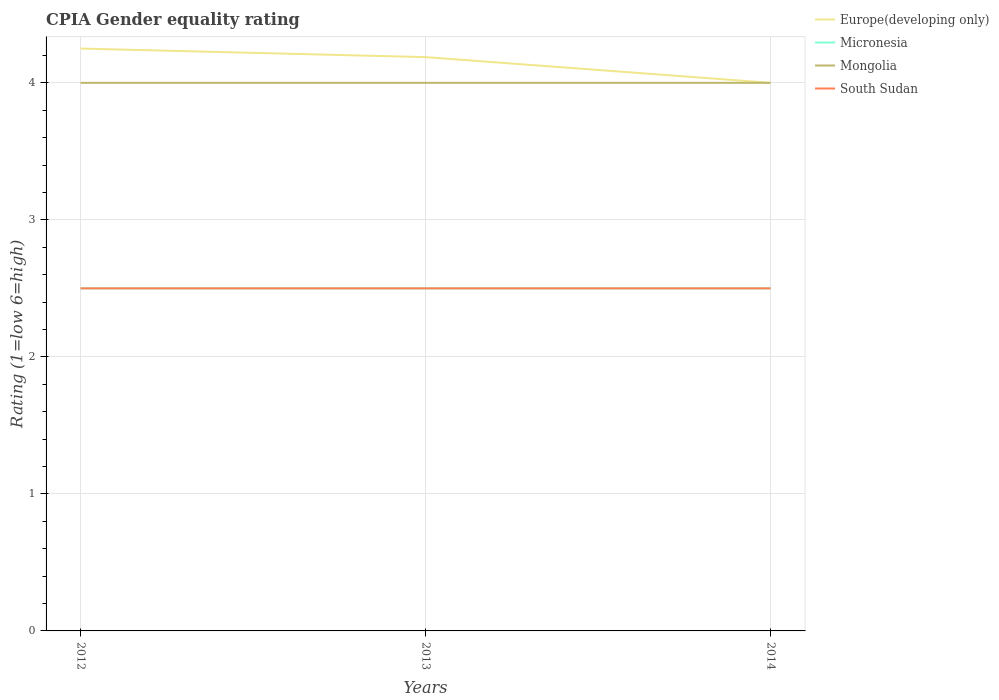How many different coloured lines are there?
Your answer should be very brief. 4. Does the line corresponding to Europe(developing only) intersect with the line corresponding to South Sudan?
Give a very brief answer. No. Across all years, what is the maximum CPIA rating in Europe(developing only)?
Keep it short and to the point. 4. What is the difference between the highest and the lowest CPIA rating in Europe(developing only)?
Provide a succinct answer. 2. Is the CPIA rating in Europe(developing only) strictly greater than the CPIA rating in South Sudan over the years?
Make the answer very short. No. How many years are there in the graph?
Your response must be concise. 3. Does the graph contain any zero values?
Keep it short and to the point. No. Where does the legend appear in the graph?
Give a very brief answer. Top right. What is the title of the graph?
Offer a terse response. CPIA Gender equality rating. What is the label or title of the X-axis?
Offer a terse response. Years. What is the label or title of the Y-axis?
Ensure brevity in your answer.  Rating (1=low 6=high). What is the Rating (1=low 6=high) of Europe(developing only) in 2012?
Your response must be concise. 4.25. What is the Rating (1=low 6=high) of Europe(developing only) in 2013?
Make the answer very short. 4.19. What is the Rating (1=low 6=high) of Micronesia in 2013?
Provide a short and direct response. 2.5. What is the Rating (1=low 6=high) in Mongolia in 2013?
Your response must be concise. 4. What is the Rating (1=low 6=high) of Europe(developing only) in 2014?
Provide a succinct answer. 4. What is the Rating (1=low 6=high) in Micronesia in 2014?
Offer a very short reply. 2.5. What is the Rating (1=low 6=high) in Mongolia in 2014?
Your response must be concise. 4. What is the Rating (1=low 6=high) in South Sudan in 2014?
Give a very brief answer. 2.5. Across all years, what is the maximum Rating (1=low 6=high) of Europe(developing only)?
Your response must be concise. 4.25. Across all years, what is the maximum Rating (1=low 6=high) of Micronesia?
Your answer should be compact. 2.5. Across all years, what is the minimum Rating (1=low 6=high) of Europe(developing only)?
Your answer should be very brief. 4. Across all years, what is the minimum Rating (1=low 6=high) in Mongolia?
Give a very brief answer. 4. Across all years, what is the minimum Rating (1=low 6=high) of South Sudan?
Your answer should be very brief. 2.5. What is the total Rating (1=low 6=high) of Europe(developing only) in the graph?
Your response must be concise. 12.44. What is the total Rating (1=low 6=high) in South Sudan in the graph?
Provide a succinct answer. 7.5. What is the difference between the Rating (1=low 6=high) of Europe(developing only) in 2012 and that in 2013?
Keep it short and to the point. 0.06. What is the difference between the Rating (1=low 6=high) of Mongolia in 2012 and that in 2013?
Give a very brief answer. 0. What is the difference between the Rating (1=low 6=high) of Europe(developing only) in 2012 and that in 2014?
Your answer should be very brief. 0.25. What is the difference between the Rating (1=low 6=high) of Micronesia in 2012 and that in 2014?
Your answer should be compact. 0. What is the difference between the Rating (1=low 6=high) of Mongolia in 2012 and that in 2014?
Keep it short and to the point. 0. What is the difference between the Rating (1=low 6=high) in Europe(developing only) in 2013 and that in 2014?
Your answer should be very brief. 0.19. What is the difference between the Rating (1=low 6=high) of Micronesia in 2012 and the Rating (1=low 6=high) of Mongolia in 2013?
Your answer should be compact. -1.5. What is the difference between the Rating (1=low 6=high) in Micronesia in 2012 and the Rating (1=low 6=high) in South Sudan in 2013?
Provide a short and direct response. 0. What is the difference between the Rating (1=low 6=high) of Mongolia in 2012 and the Rating (1=low 6=high) of South Sudan in 2013?
Keep it short and to the point. 1.5. What is the difference between the Rating (1=low 6=high) of Europe(developing only) in 2012 and the Rating (1=low 6=high) of Micronesia in 2014?
Give a very brief answer. 1.75. What is the difference between the Rating (1=low 6=high) in Micronesia in 2012 and the Rating (1=low 6=high) in Mongolia in 2014?
Your answer should be compact. -1.5. What is the difference between the Rating (1=low 6=high) of Micronesia in 2012 and the Rating (1=low 6=high) of South Sudan in 2014?
Give a very brief answer. 0. What is the difference between the Rating (1=low 6=high) of Europe(developing only) in 2013 and the Rating (1=low 6=high) of Micronesia in 2014?
Make the answer very short. 1.69. What is the difference between the Rating (1=low 6=high) of Europe(developing only) in 2013 and the Rating (1=low 6=high) of Mongolia in 2014?
Offer a very short reply. 0.19. What is the difference between the Rating (1=low 6=high) in Europe(developing only) in 2013 and the Rating (1=low 6=high) in South Sudan in 2014?
Offer a terse response. 1.69. What is the difference between the Rating (1=low 6=high) of Micronesia in 2013 and the Rating (1=low 6=high) of Mongolia in 2014?
Make the answer very short. -1.5. What is the difference between the Rating (1=low 6=high) in Micronesia in 2013 and the Rating (1=low 6=high) in South Sudan in 2014?
Ensure brevity in your answer.  0. What is the difference between the Rating (1=low 6=high) of Mongolia in 2013 and the Rating (1=low 6=high) of South Sudan in 2014?
Make the answer very short. 1.5. What is the average Rating (1=low 6=high) of Europe(developing only) per year?
Give a very brief answer. 4.15. What is the average Rating (1=low 6=high) of Mongolia per year?
Your response must be concise. 4. In the year 2012, what is the difference between the Rating (1=low 6=high) in Europe(developing only) and Rating (1=low 6=high) in Mongolia?
Ensure brevity in your answer.  0.25. In the year 2012, what is the difference between the Rating (1=low 6=high) in Micronesia and Rating (1=low 6=high) in South Sudan?
Your response must be concise. 0. In the year 2013, what is the difference between the Rating (1=low 6=high) of Europe(developing only) and Rating (1=low 6=high) of Micronesia?
Provide a succinct answer. 1.69. In the year 2013, what is the difference between the Rating (1=low 6=high) in Europe(developing only) and Rating (1=low 6=high) in Mongolia?
Provide a succinct answer. 0.19. In the year 2013, what is the difference between the Rating (1=low 6=high) in Europe(developing only) and Rating (1=low 6=high) in South Sudan?
Your answer should be very brief. 1.69. In the year 2013, what is the difference between the Rating (1=low 6=high) of Micronesia and Rating (1=low 6=high) of Mongolia?
Your response must be concise. -1.5. In the year 2013, what is the difference between the Rating (1=low 6=high) in Mongolia and Rating (1=low 6=high) in South Sudan?
Your answer should be compact. 1.5. In the year 2014, what is the difference between the Rating (1=low 6=high) of Europe(developing only) and Rating (1=low 6=high) of Micronesia?
Make the answer very short. 1.5. In the year 2014, what is the difference between the Rating (1=low 6=high) in Micronesia and Rating (1=low 6=high) in South Sudan?
Keep it short and to the point. 0. What is the ratio of the Rating (1=low 6=high) in Europe(developing only) in 2012 to that in 2013?
Make the answer very short. 1.01. What is the ratio of the Rating (1=low 6=high) of Micronesia in 2012 to that in 2013?
Ensure brevity in your answer.  1. What is the ratio of the Rating (1=low 6=high) in Mongolia in 2012 to that in 2013?
Make the answer very short. 1. What is the ratio of the Rating (1=low 6=high) of South Sudan in 2012 to that in 2014?
Keep it short and to the point. 1. What is the ratio of the Rating (1=low 6=high) in Europe(developing only) in 2013 to that in 2014?
Make the answer very short. 1.05. What is the ratio of the Rating (1=low 6=high) of Micronesia in 2013 to that in 2014?
Ensure brevity in your answer.  1. What is the ratio of the Rating (1=low 6=high) of South Sudan in 2013 to that in 2014?
Your answer should be very brief. 1. What is the difference between the highest and the second highest Rating (1=low 6=high) of Europe(developing only)?
Offer a terse response. 0.06. What is the difference between the highest and the second highest Rating (1=low 6=high) in Mongolia?
Give a very brief answer. 0. What is the difference between the highest and the second highest Rating (1=low 6=high) of South Sudan?
Provide a succinct answer. 0. What is the difference between the highest and the lowest Rating (1=low 6=high) in Europe(developing only)?
Provide a succinct answer. 0.25. What is the difference between the highest and the lowest Rating (1=low 6=high) in Micronesia?
Your answer should be compact. 0. 